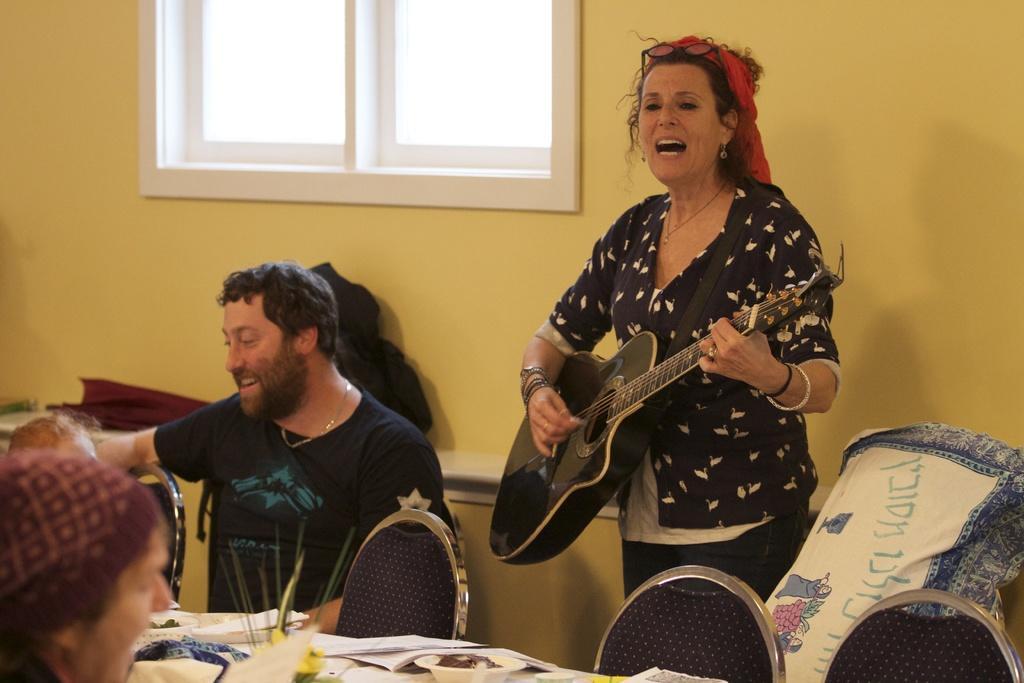In one or two sentences, can you explain what this image depicts? In this image there is a woman who is playing the guitar in the middle of the room. Beside the woman there is a man who is sitting and there is a table in front of him. On the table there are bowl,paper on it. In the background there is wall and a window. 